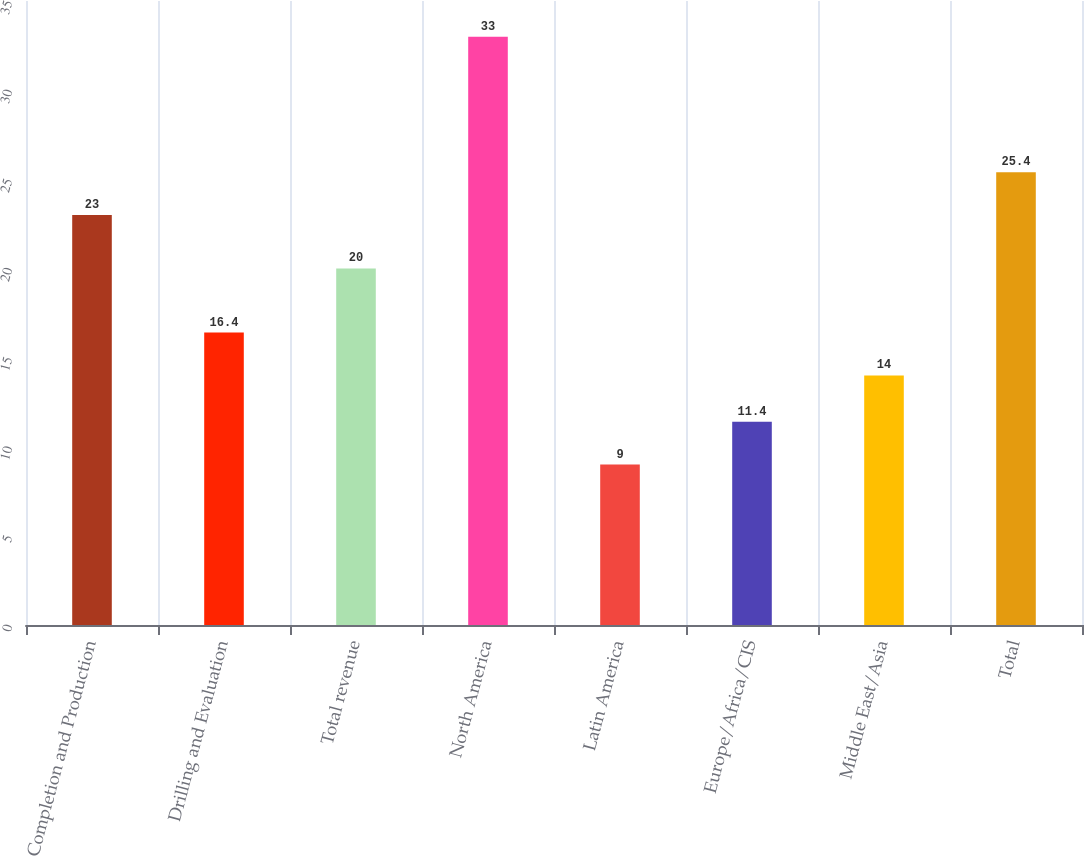<chart> <loc_0><loc_0><loc_500><loc_500><bar_chart><fcel>Completion and Production<fcel>Drilling and Evaluation<fcel>Total revenue<fcel>North America<fcel>Latin America<fcel>Europe/Africa/CIS<fcel>Middle East/Asia<fcel>Total<nl><fcel>23<fcel>16.4<fcel>20<fcel>33<fcel>9<fcel>11.4<fcel>14<fcel>25.4<nl></chart> 